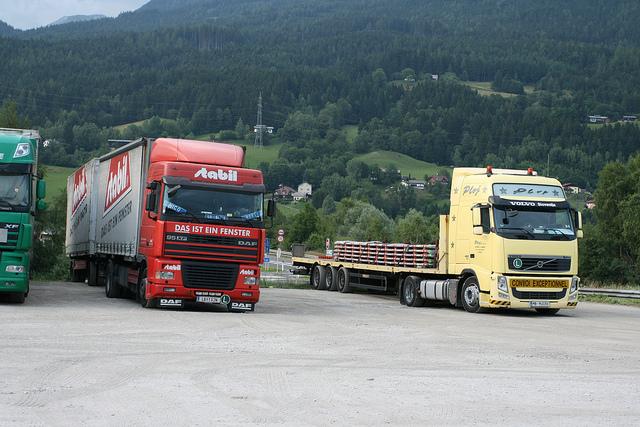Is this a military vehicle?
Write a very short answer. No. Has there been an accident?
Quick response, please. No. Which truck is yellow?
Write a very short answer. Right. What highway route is on the vehicle?
Short answer required. 0. What color is the truck?
Write a very short answer. Yellow. Are the trucks lights on?
Be succinct. No. How many wheels are visible in this picture?
Concise answer only. 9. What is the function of the yellow truck?
Be succinct. Carries cargo. What is the name of the company this truck is driving for?
Be succinct. Bill. Where are the trucks parked?
Answer briefly. Parking lot. How many trucks are on the street?
Short answer required. 3. Is this a junk yard?
Answer briefly. No. What is in background?
Answer briefly. Trees. What are the trucks parted on?
Short answer required. Concrete. Do the truck look the same?
Write a very short answer. No. What color are the trucks?
Keep it brief. Red. How many trucks are in the picture?
Answer briefly. 3. How many squares are on the truck?
Give a very brief answer. 10. Is this a Mack truck?
Keep it brief. No. How many vehicles are there?
Keep it brief. 3. 